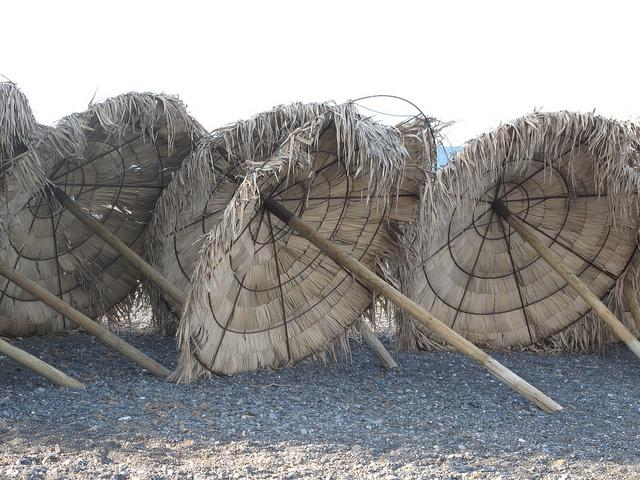What style of umbrella is seen here?

Choices:
A) cruising
B) nylon
C) thatched
D) modern thatched 